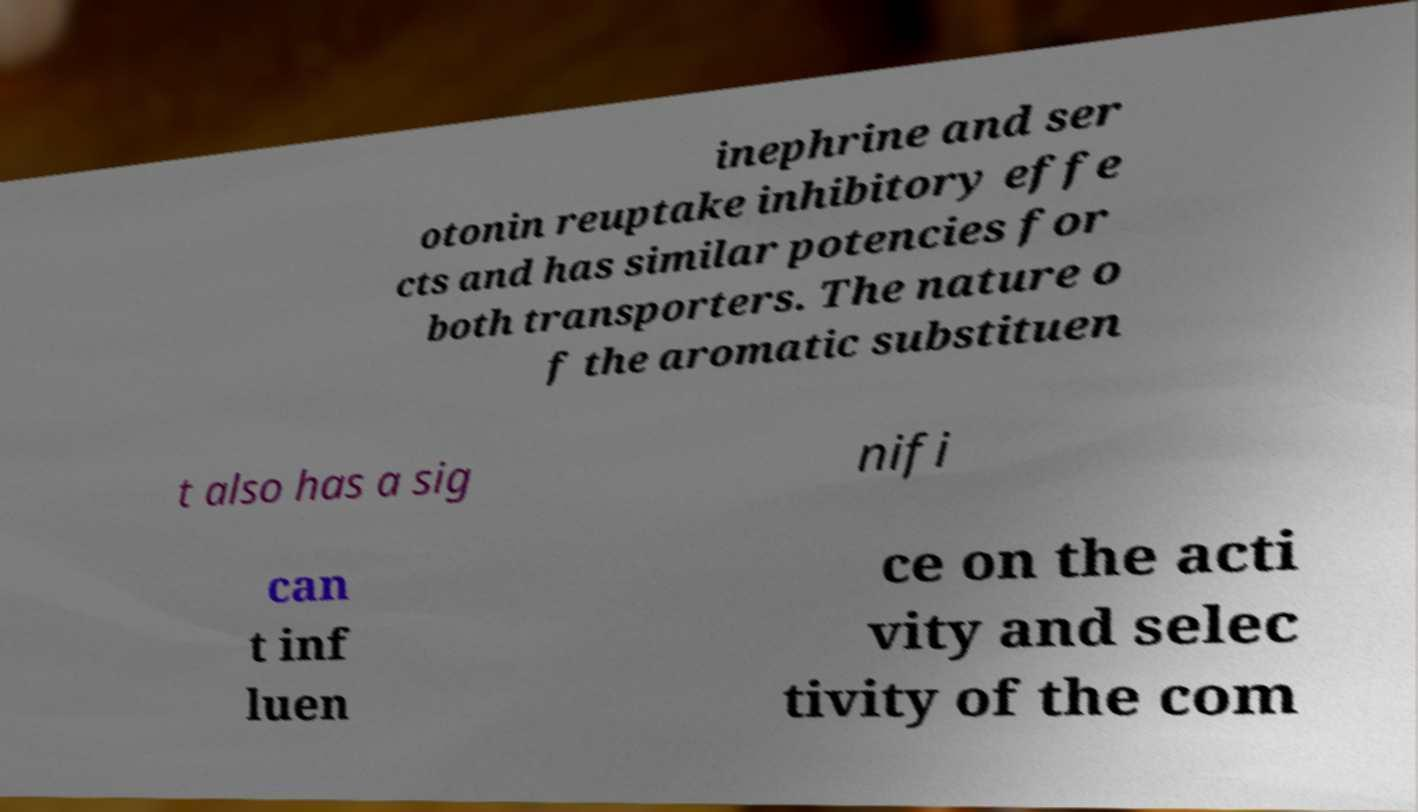I need the written content from this picture converted into text. Can you do that? inephrine and ser otonin reuptake inhibitory effe cts and has similar potencies for both transporters. The nature o f the aromatic substituen t also has a sig nifi can t inf luen ce on the acti vity and selec tivity of the com 